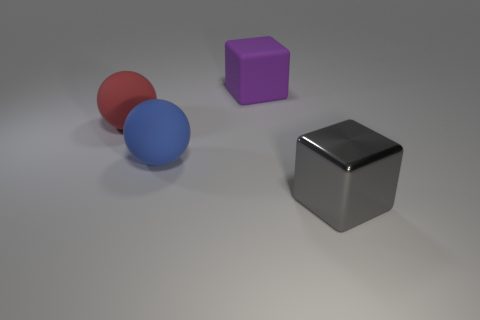Is there a purple block that has the same material as the blue ball?
Provide a succinct answer. Yes. Are there fewer large spheres on the right side of the large gray thing than objects?
Give a very brief answer. Yes. There is a cube that is on the left side of the metal block; does it have the same size as the shiny block?
Your response must be concise. Yes. How many other matte things have the same shape as the big red matte object?
Make the answer very short. 1. Are there the same number of big blue rubber objects that are in front of the large red ball and tiny yellow things?
Ensure brevity in your answer.  No. There is a large object in front of the large blue rubber object; does it have the same shape as the large rubber object that is to the left of the blue object?
Offer a very short reply. No. What is the material of the big gray object that is the same shape as the purple thing?
Provide a short and direct response. Metal. The thing that is both on the right side of the big blue rubber ball and in front of the large red matte object is what color?
Make the answer very short. Gray. Is there a metal thing that is right of the big block right of the big cube that is behind the metallic cube?
Your answer should be very brief. No. What number of things are either small yellow rubber balls or large gray shiny things?
Offer a terse response. 1. 